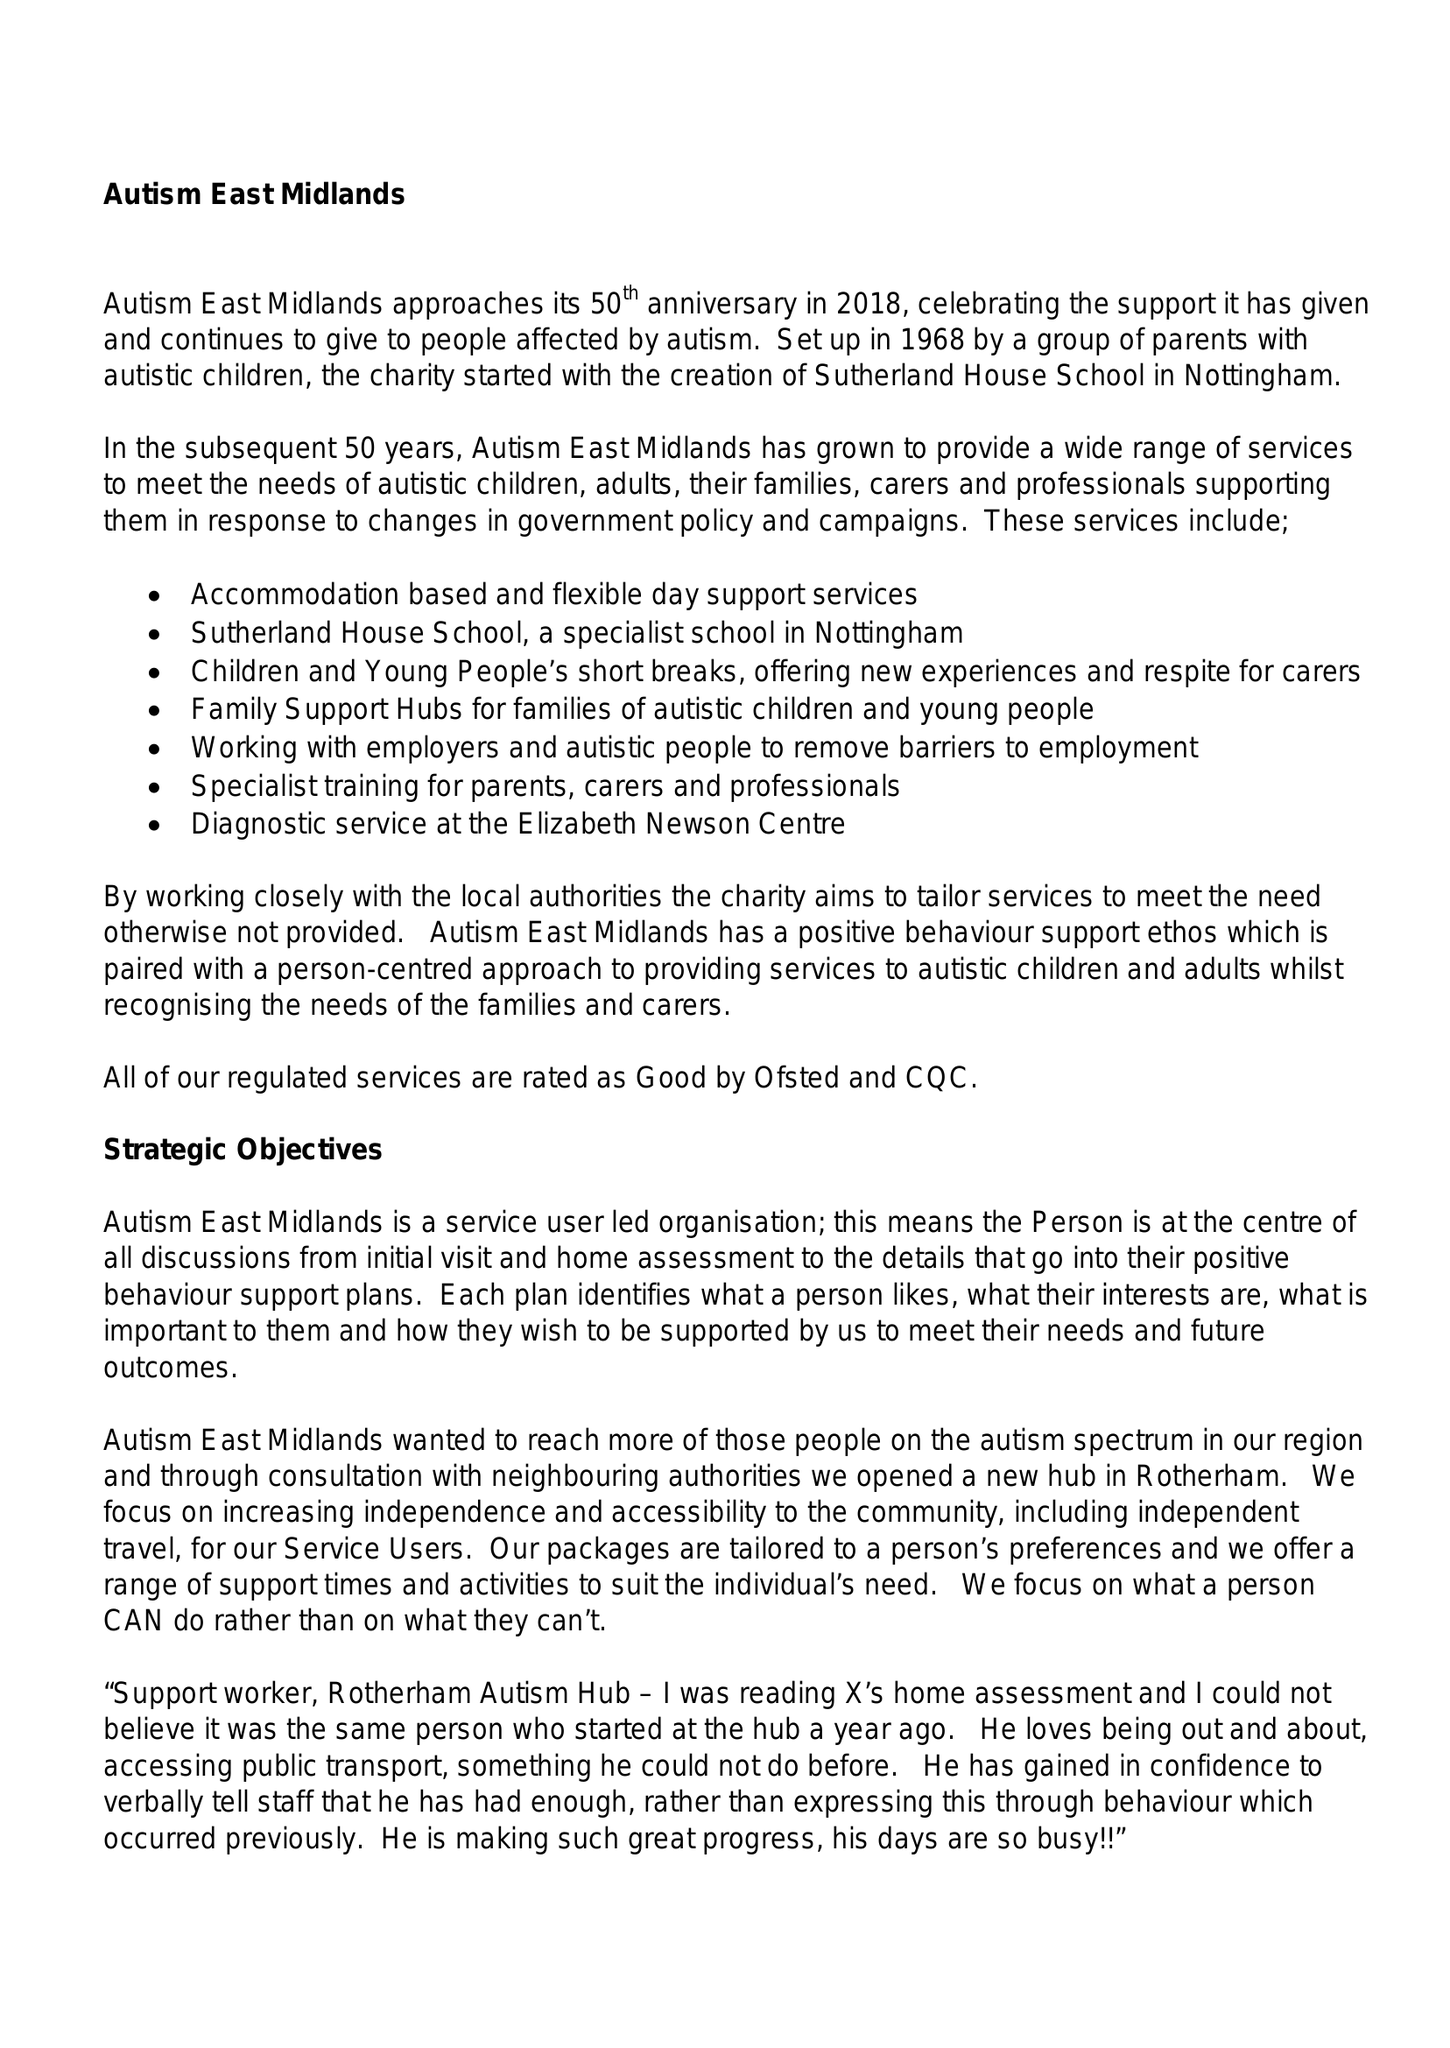What is the value for the charity_name?
Answer the question using a single word or phrase. Autism East Midlands 